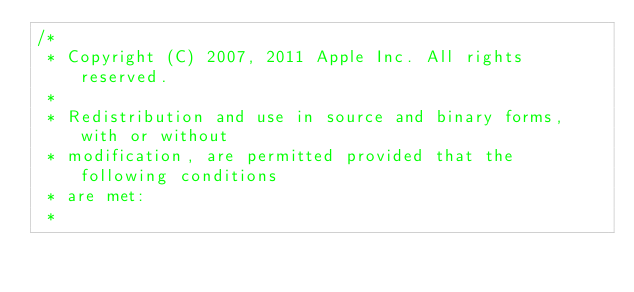<code> <loc_0><loc_0><loc_500><loc_500><_ObjectiveC_>/*
 * Copyright (C) 2007, 2011 Apple Inc. All rights reserved.
 *
 * Redistribution and use in source and binary forms, with or without
 * modification, are permitted provided that the following conditions
 * are met:
 *</code> 